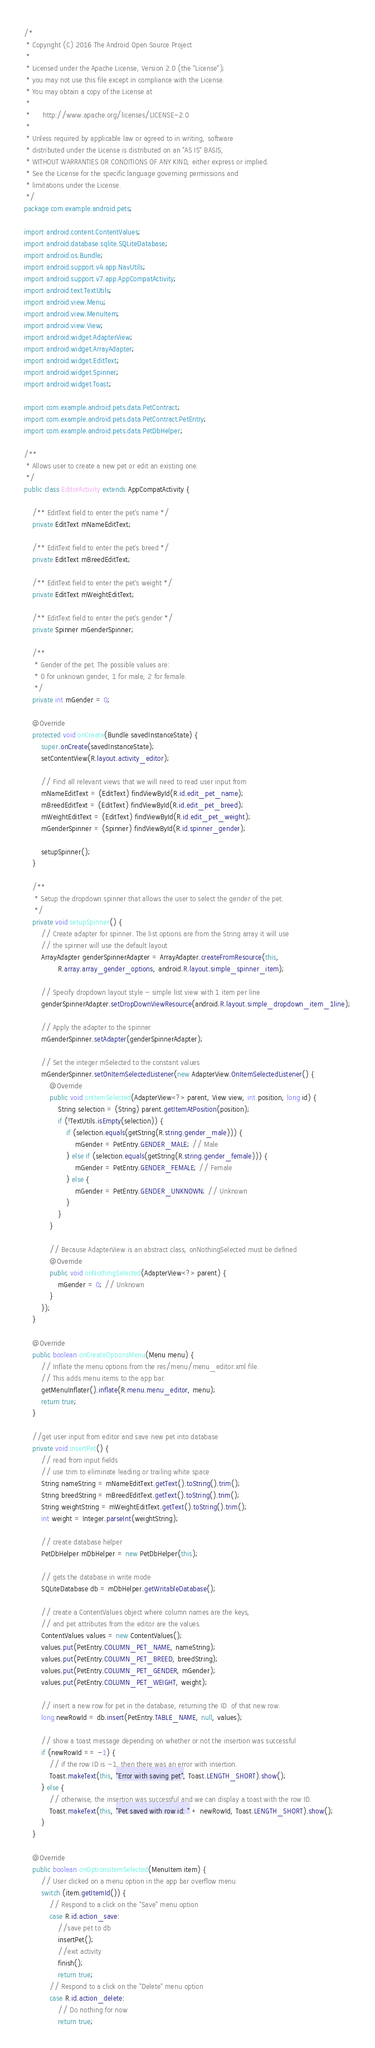<code> <loc_0><loc_0><loc_500><loc_500><_Java_>/*
 * Copyright (C) 2016 The Android Open Source Project
 *
 * Licensed under the Apache License, Version 2.0 (the "License");
 * you may not use this file except in compliance with the License.
 * You may obtain a copy of the License at
 *
 *      http://www.apache.org/licenses/LICENSE-2.0
 *
 * Unless required by applicable law or agreed to in writing, software
 * distributed under the License is distributed on an "AS IS" BASIS,
 * WITHOUT WARRANTIES OR CONDITIONS OF ANY KIND, either express or implied.
 * See the License for the specific language governing permissions and
 * limitations under the License.
 */
package com.example.android.pets;

import android.content.ContentValues;
import android.database.sqlite.SQLiteDatabase;
import android.os.Bundle;
import android.support.v4.app.NavUtils;
import android.support.v7.app.AppCompatActivity;
import android.text.TextUtils;
import android.view.Menu;
import android.view.MenuItem;
import android.view.View;
import android.widget.AdapterView;
import android.widget.ArrayAdapter;
import android.widget.EditText;
import android.widget.Spinner;
import android.widget.Toast;

import com.example.android.pets.data.PetContract;
import com.example.android.pets.data.PetContract.PetEntry;
import com.example.android.pets.data.PetDbHelper;

/**
 * Allows user to create a new pet or edit an existing one.
 */
public class EditorActivity extends AppCompatActivity {

    /** EditText field to enter the pet's name */
    private EditText mNameEditText;

    /** EditText field to enter the pet's breed */
    private EditText mBreedEditText;

    /** EditText field to enter the pet's weight */
    private EditText mWeightEditText;

    /** EditText field to enter the pet's gender */
    private Spinner mGenderSpinner;

    /**
     * Gender of the pet. The possible values are:
     * 0 for unknown gender, 1 for male, 2 for female.
     */
    private int mGender = 0;

    @Override
    protected void onCreate(Bundle savedInstanceState) {
        super.onCreate(savedInstanceState);
        setContentView(R.layout.activity_editor);

        // Find all relevant views that we will need to read user input from
        mNameEditText = (EditText) findViewById(R.id.edit_pet_name);
        mBreedEditText = (EditText) findViewById(R.id.edit_pet_breed);
        mWeightEditText = (EditText) findViewById(R.id.edit_pet_weight);
        mGenderSpinner = (Spinner) findViewById(R.id.spinner_gender);

        setupSpinner();
    }

    /**
     * Setup the dropdown spinner that allows the user to select the gender of the pet.
     */
    private void setupSpinner() {
        // Create adapter for spinner. The list options are from the String array it will use
        // the spinner will use the default layout
        ArrayAdapter genderSpinnerAdapter = ArrayAdapter.createFromResource(this,
                R.array.array_gender_options, android.R.layout.simple_spinner_item);

        // Specify dropdown layout style - simple list view with 1 item per line
        genderSpinnerAdapter.setDropDownViewResource(android.R.layout.simple_dropdown_item_1line);

        // Apply the adapter to the spinner
        mGenderSpinner.setAdapter(genderSpinnerAdapter);

        // Set the integer mSelected to the constant values
        mGenderSpinner.setOnItemSelectedListener(new AdapterView.OnItemSelectedListener() {
            @Override
            public void onItemSelected(AdapterView<?> parent, View view, int position, long id) {
                String selection = (String) parent.getItemAtPosition(position);
                if (!TextUtils.isEmpty(selection)) {
                    if (selection.equals(getString(R.string.gender_male))) {
                        mGender = PetEntry.GENDER_MALE; // Male
                    } else if (selection.equals(getString(R.string.gender_female))) {
                        mGender = PetEntry.GENDER_FEMALE; // Female
                    } else {
                        mGender = PetEntry.GENDER_UNKNOWN; // Unknown
                    }
                }
            }

            // Because AdapterView is an abstract class, onNothingSelected must be defined
            @Override
            public void onNothingSelected(AdapterView<?> parent) {
                mGender = 0; // Unknown
            }
        });
    }

    @Override
    public boolean onCreateOptionsMenu(Menu menu) {
        // Inflate the menu options from the res/menu/menu_editor.xml file.
        // This adds menu items to the app bar.
        getMenuInflater().inflate(R.menu.menu_editor, menu);
        return true;
    }

    //get user input from editor and save new pet into database
    private void insertPet() {
        // read from input fields
        // use trim to eliminate leading or trailing white space
        String nameString = mNameEditText.getText().toString().trim();
        String breedString = mBreedEditText.getText().toString().trim();
        String weightString = mWeightEditText.getText().toString().trim();
        int weight = Integer.parseInt(weightString);

        // create database helper
        PetDbHelper mDbHelper = new PetDbHelper(this);

        // gets the database in write mode
        SQLiteDatabase db = mDbHelper.getWritableDatabase();

        // create a ContentValues object where column names are the keys,
        // and pet attributes from the editor are the values.
        ContentValues values = new ContentValues();
        values.put(PetEntry.COLUMN_PET_NAME, nameString);
        values.put(PetEntry.COLUMN_PET_BREED, breedString);
        values.put(PetEntry.COLUMN_PET_GENDER, mGender);
        values.put(PetEntry.COLUMN_PET_WEIGHT, weight);

        // insert a new row for pet in the database, returning the ID  of that new row.
        long newRowId = db.insert(PetEntry.TABLE_NAME, null, values);

        // show a toast message depending on whether or not the insertion was successful
        if (newRowId == -1) {
            // if the row ID is -1, then there was an error with insertion.
            Toast.makeText(this, "Error with saving pet", Toast.LENGTH_SHORT).show();
        } else {
            // otherwise, the insertion was successful and we can display a toast with the row ID.
            Toast.makeText(this, "Pet saved with row id: " + newRowId, Toast.LENGTH_SHORT).show();
        }
    }

    @Override
    public boolean onOptionsItemSelected(MenuItem item) {
        // User clicked on a menu option in the app bar overflow menu
        switch (item.getItemId()) {
            // Respond to a click on the "Save" menu option
            case R.id.action_save:
                //save pet to db
                insertPet();
                //exit activity
                finish();
                return true;
            // Respond to a click on the "Delete" menu option
            case R.id.action_delete:
                // Do nothing for now
                return true;</code> 